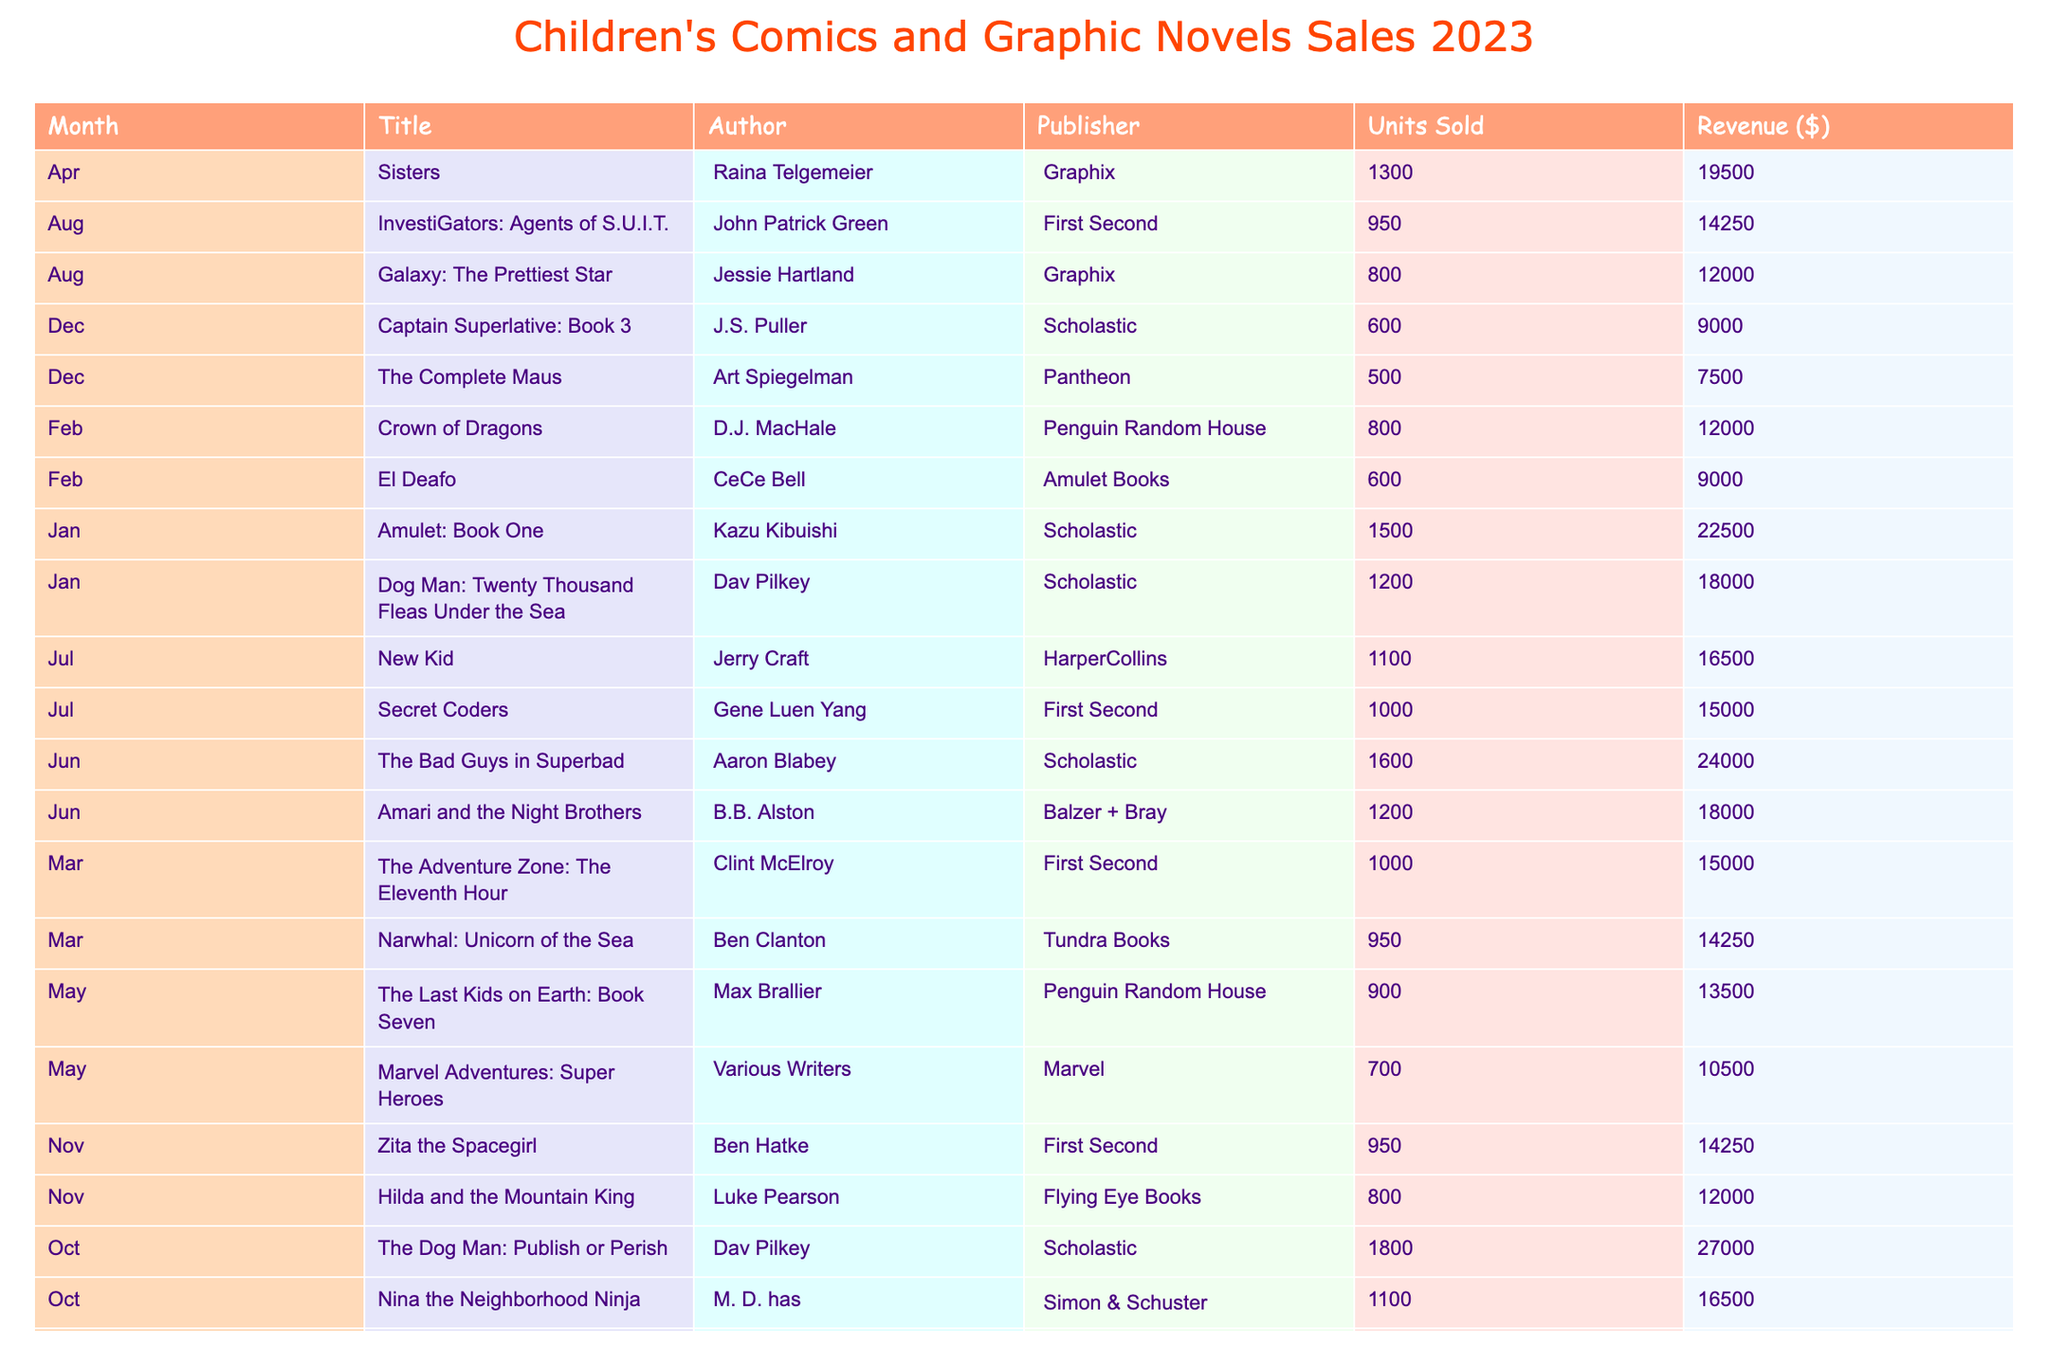What title had the highest revenue in October? In October, "The Dog Man: Publish or Perish" had a revenue of $27,000, which is higher than the revenue of "Nina the Neighborhood Ninja," which was $16,500. Thus, it holds the top spot in terms of revenue for that month.
Answer: The Dog Man: Publish or Perish Which month had the most units sold for children's comics? By looking at the total units sold in the table, we can sum them for each month. In October, the total units sold was 2,900 (1,800 + 1,100), which is the highest compared to other months.
Answer: October Is "Crown of Dragons" sold more than "El Deafo"? "Crown of Dragons" sold 800 units, while "El Deafo" sold 600 units. Since 800 is greater than 600, "Crown of Dragons" sold more.
Answer: Yes What is the average revenue of the comics sold in June? In June, there are two titles with revenues of $18,000 and $24,000. The total revenue is $18,000 + $24,000 = $42,000. To find the average, divide by 2, which gives $42,000 / 2 = $21,000.
Answer: 21,000 Which author sold more units, Kazu Kibuishi or Dav Pilkey? Kazu Kibuishi's title sold 1,500 units ("Amulet: Book One"), while Dav Pilkey's title sold 1,200 units ("Dog Man: Twenty Thousand Fleas Under the Sea"). Therefore, Kibuishi sold more units than Pilkey.
Answer: Kazu Kibuishi How many titles were sold by First Second publishers throughout the year? The table shows three titles from First Second: "The Adventure Zone: The Eleventh Hour," "Secret Coders," and "InvestiGators: Agents of S.U.I.T." Hence, First Second published a total of three titles.
Answer: 3 What is the total revenue from all sales in May? In May, "The Last Kids on Earth: Book Seven" generated $13,500 and "Marvel Adventures: Super Heroes" made $10,500. Adding these together gives total revenue = $13,500 + $10,500 = $24,000.
Answer: 24,000 Did any title sell more than 1,800 units? The maximum units sold in the table is 1,800 for "The Dog Man: Publish or Perish." Thus, there were no other titles sold that exceeded this amount.
Answer: No 